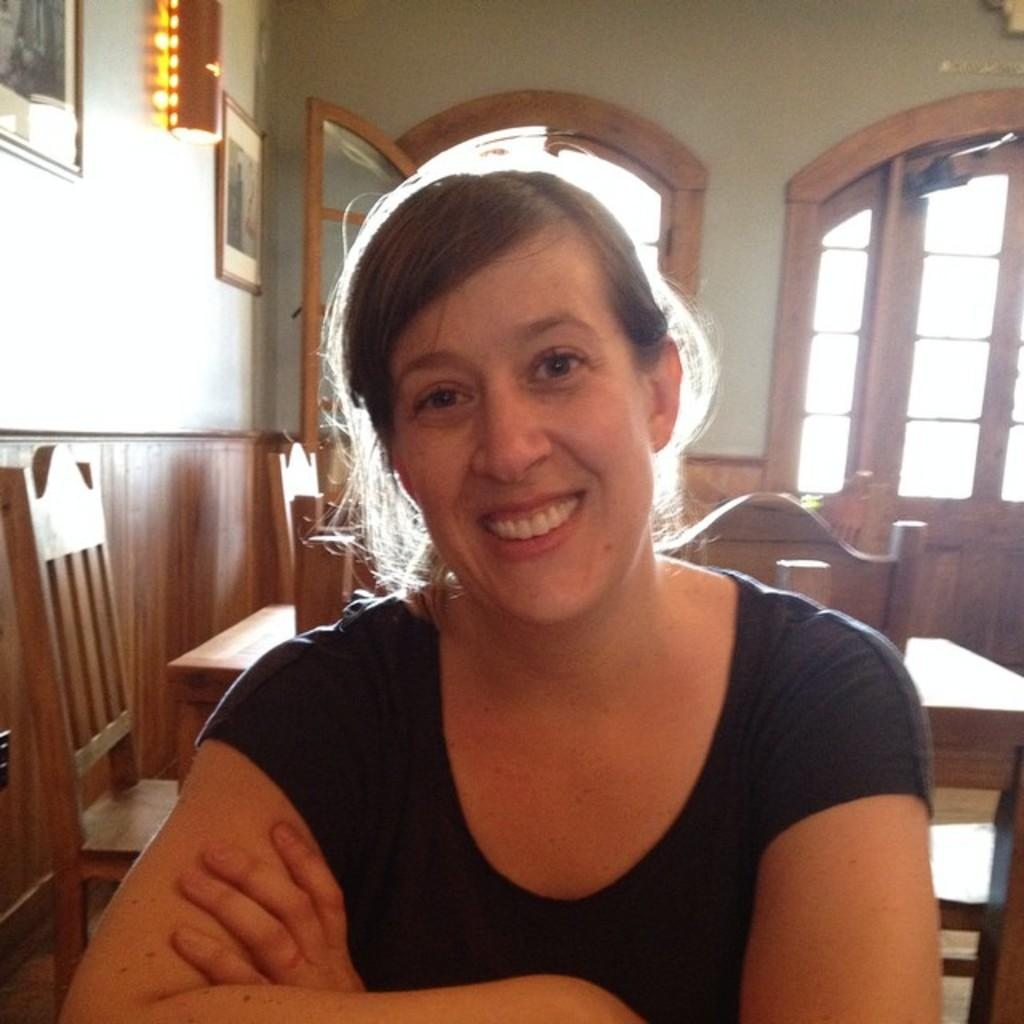What type of furniture is visible in the image? There are tables and chairs in the image. Can you describe the person in the image? A person is sitting in the front of the image, and they are wearing a navy blue shirt. What is located on the left side of the image? There are frames on the left side of the image. What architectural feature is in the middle of the image? There is a door in the middle of the image. How many girls are having lunch in the image? There is no mention of girls or lunch in the image; it features tables, chairs, a person, frames, and a door. Where is the drain located in the image? There is no drain present in the image. 